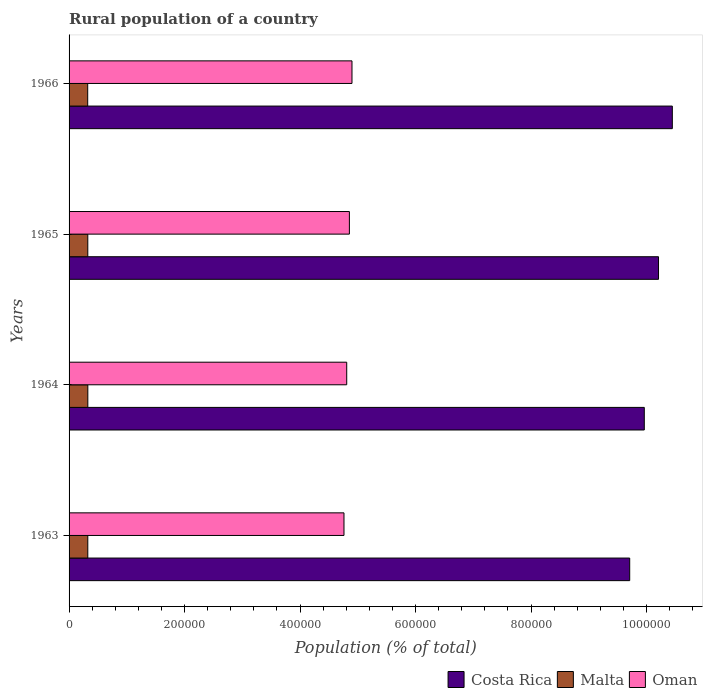How many different coloured bars are there?
Your response must be concise. 3. How many groups of bars are there?
Provide a short and direct response. 4. Are the number of bars per tick equal to the number of legend labels?
Keep it short and to the point. Yes. In how many cases, is the number of bars for a given year not equal to the number of legend labels?
Your answer should be compact. 0. What is the rural population in Oman in 1965?
Provide a succinct answer. 4.85e+05. Across all years, what is the maximum rural population in Costa Rica?
Give a very brief answer. 1.04e+06. Across all years, what is the minimum rural population in Oman?
Offer a very short reply. 4.76e+05. In which year was the rural population in Malta maximum?
Offer a very short reply. 1964. What is the total rural population in Malta in the graph?
Your answer should be compact. 1.30e+05. What is the difference between the rural population in Oman in 1964 and that in 1965?
Your response must be concise. -4614. What is the difference between the rural population in Costa Rica in 1966 and the rural population in Oman in 1963?
Give a very brief answer. 5.69e+05. What is the average rural population in Costa Rica per year?
Give a very brief answer. 1.01e+06. In the year 1966, what is the difference between the rural population in Malta and rural population in Oman?
Ensure brevity in your answer.  -4.58e+05. What is the ratio of the rural population in Malta in 1963 to that in 1964?
Give a very brief answer. 1. Is the rural population in Malta in 1965 less than that in 1966?
Provide a short and direct response. No. What is the difference between the highest and the lowest rural population in Malta?
Your answer should be very brief. 227. In how many years, is the rural population in Costa Rica greater than the average rural population in Costa Rica taken over all years?
Give a very brief answer. 2. What does the 1st bar from the bottom in 1963 represents?
Provide a succinct answer. Costa Rica. How many bars are there?
Ensure brevity in your answer.  12. How many years are there in the graph?
Ensure brevity in your answer.  4. Does the graph contain any zero values?
Offer a terse response. No. Does the graph contain grids?
Give a very brief answer. No. Where does the legend appear in the graph?
Offer a terse response. Bottom right. How many legend labels are there?
Your answer should be very brief. 3. What is the title of the graph?
Provide a succinct answer. Rural population of a country. Does "Togo" appear as one of the legend labels in the graph?
Give a very brief answer. No. What is the label or title of the X-axis?
Make the answer very short. Population (% of total). What is the label or title of the Y-axis?
Ensure brevity in your answer.  Years. What is the Population (% of total) of Costa Rica in 1963?
Provide a short and direct response. 9.71e+05. What is the Population (% of total) in Malta in 1963?
Offer a terse response. 3.24e+04. What is the Population (% of total) in Oman in 1963?
Provide a succinct answer. 4.76e+05. What is the Population (% of total) of Costa Rica in 1964?
Provide a short and direct response. 9.96e+05. What is the Population (% of total) in Malta in 1964?
Make the answer very short. 3.25e+04. What is the Population (% of total) in Oman in 1964?
Your response must be concise. 4.81e+05. What is the Population (% of total) in Costa Rica in 1965?
Your answer should be very brief. 1.02e+06. What is the Population (% of total) in Malta in 1965?
Your response must be concise. 3.24e+04. What is the Population (% of total) of Oman in 1965?
Provide a short and direct response. 4.85e+05. What is the Population (% of total) in Costa Rica in 1966?
Offer a terse response. 1.04e+06. What is the Population (% of total) in Malta in 1966?
Provide a short and direct response. 3.23e+04. What is the Population (% of total) in Oman in 1966?
Offer a terse response. 4.90e+05. Across all years, what is the maximum Population (% of total) of Costa Rica?
Give a very brief answer. 1.04e+06. Across all years, what is the maximum Population (% of total) of Malta?
Offer a terse response. 3.25e+04. Across all years, what is the maximum Population (% of total) in Oman?
Your answer should be compact. 4.90e+05. Across all years, what is the minimum Population (% of total) in Costa Rica?
Provide a short and direct response. 9.71e+05. Across all years, what is the minimum Population (% of total) in Malta?
Offer a very short reply. 3.23e+04. Across all years, what is the minimum Population (% of total) in Oman?
Offer a very short reply. 4.76e+05. What is the total Population (% of total) in Costa Rica in the graph?
Ensure brevity in your answer.  4.03e+06. What is the total Population (% of total) of Malta in the graph?
Ensure brevity in your answer.  1.30e+05. What is the total Population (% of total) in Oman in the graph?
Keep it short and to the point. 1.93e+06. What is the difference between the Population (% of total) of Costa Rica in 1963 and that in 1964?
Offer a terse response. -2.53e+04. What is the difference between the Population (% of total) in Malta in 1963 and that in 1964?
Your answer should be compact. -68. What is the difference between the Population (% of total) of Oman in 1963 and that in 1964?
Provide a succinct answer. -4753. What is the difference between the Population (% of total) in Costa Rica in 1963 and that in 1965?
Your answer should be very brief. -4.99e+04. What is the difference between the Population (% of total) of Oman in 1963 and that in 1965?
Your answer should be compact. -9367. What is the difference between the Population (% of total) in Costa Rica in 1963 and that in 1966?
Offer a very short reply. -7.38e+04. What is the difference between the Population (% of total) of Malta in 1963 and that in 1966?
Make the answer very short. 159. What is the difference between the Population (% of total) in Oman in 1963 and that in 1966?
Make the answer very short. -1.39e+04. What is the difference between the Population (% of total) in Costa Rica in 1964 and that in 1965?
Make the answer very short. -2.46e+04. What is the difference between the Population (% of total) of Malta in 1964 and that in 1965?
Make the answer very short. 53. What is the difference between the Population (% of total) of Oman in 1964 and that in 1965?
Provide a succinct answer. -4614. What is the difference between the Population (% of total) in Costa Rica in 1964 and that in 1966?
Give a very brief answer. -4.86e+04. What is the difference between the Population (% of total) of Malta in 1964 and that in 1966?
Give a very brief answer. 227. What is the difference between the Population (% of total) of Oman in 1964 and that in 1966?
Offer a terse response. -9109. What is the difference between the Population (% of total) in Costa Rica in 1965 and that in 1966?
Provide a succinct answer. -2.39e+04. What is the difference between the Population (% of total) in Malta in 1965 and that in 1966?
Your answer should be compact. 174. What is the difference between the Population (% of total) in Oman in 1965 and that in 1966?
Offer a very short reply. -4495. What is the difference between the Population (% of total) of Costa Rica in 1963 and the Population (% of total) of Malta in 1964?
Ensure brevity in your answer.  9.38e+05. What is the difference between the Population (% of total) in Costa Rica in 1963 and the Population (% of total) in Oman in 1964?
Keep it short and to the point. 4.90e+05. What is the difference between the Population (% of total) in Malta in 1963 and the Population (% of total) in Oman in 1964?
Ensure brevity in your answer.  -4.48e+05. What is the difference between the Population (% of total) in Costa Rica in 1963 and the Population (% of total) in Malta in 1965?
Provide a short and direct response. 9.38e+05. What is the difference between the Population (% of total) of Costa Rica in 1963 and the Population (% of total) of Oman in 1965?
Your response must be concise. 4.85e+05. What is the difference between the Population (% of total) of Malta in 1963 and the Population (% of total) of Oman in 1965?
Your response must be concise. -4.53e+05. What is the difference between the Population (% of total) of Costa Rica in 1963 and the Population (% of total) of Malta in 1966?
Offer a terse response. 9.39e+05. What is the difference between the Population (% of total) in Costa Rica in 1963 and the Population (% of total) in Oman in 1966?
Ensure brevity in your answer.  4.81e+05. What is the difference between the Population (% of total) in Malta in 1963 and the Population (% of total) in Oman in 1966?
Provide a short and direct response. -4.57e+05. What is the difference between the Population (% of total) of Costa Rica in 1964 and the Population (% of total) of Malta in 1965?
Provide a succinct answer. 9.64e+05. What is the difference between the Population (% of total) in Costa Rica in 1964 and the Population (% of total) in Oman in 1965?
Provide a succinct answer. 5.11e+05. What is the difference between the Population (% of total) in Malta in 1964 and the Population (% of total) in Oman in 1965?
Make the answer very short. -4.53e+05. What is the difference between the Population (% of total) in Costa Rica in 1964 and the Population (% of total) in Malta in 1966?
Make the answer very short. 9.64e+05. What is the difference between the Population (% of total) in Costa Rica in 1964 and the Population (% of total) in Oman in 1966?
Make the answer very short. 5.06e+05. What is the difference between the Population (% of total) in Malta in 1964 and the Population (% of total) in Oman in 1966?
Keep it short and to the point. -4.57e+05. What is the difference between the Population (% of total) of Costa Rica in 1965 and the Population (% of total) of Malta in 1966?
Ensure brevity in your answer.  9.88e+05. What is the difference between the Population (% of total) of Costa Rica in 1965 and the Population (% of total) of Oman in 1966?
Ensure brevity in your answer.  5.31e+05. What is the difference between the Population (% of total) in Malta in 1965 and the Population (% of total) in Oman in 1966?
Offer a terse response. -4.57e+05. What is the average Population (% of total) in Costa Rica per year?
Ensure brevity in your answer.  1.01e+06. What is the average Population (% of total) of Malta per year?
Provide a succinct answer. 3.24e+04. What is the average Population (% of total) in Oman per year?
Provide a succinct answer. 4.83e+05. In the year 1963, what is the difference between the Population (% of total) in Costa Rica and Population (% of total) in Malta?
Make the answer very short. 9.38e+05. In the year 1963, what is the difference between the Population (% of total) in Costa Rica and Population (% of total) in Oman?
Provide a succinct answer. 4.95e+05. In the year 1963, what is the difference between the Population (% of total) of Malta and Population (% of total) of Oman?
Provide a succinct answer. -4.44e+05. In the year 1964, what is the difference between the Population (% of total) in Costa Rica and Population (% of total) in Malta?
Make the answer very short. 9.64e+05. In the year 1964, what is the difference between the Population (% of total) of Costa Rica and Population (% of total) of Oman?
Make the answer very short. 5.15e+05. In the year 1964, what is the difference between the Population (% of total) of Malta and Population (% of total) of Oman?
Your answer should be compact. -4.48e+05. In the year 1965, what is the difference between the Population (% of total) in Costa Rica and Population (% of total) in Malta?
Provide a short and direct response. 9.88e+05. In the year 1965, what is the difference between the Population (% of total) of Costa Rica and Population (% of total) of Oman?
Provide a short and direct response. 5.35e+05. In the year 1965, what is the difference between the Population (% of total) in Malta and Population (% of total) in Oman?
Ensure brevity in your answer.  -4.53e+05. In the year 1966, what is the difference between the Population (% of total) in Costa Rica and Population (% of total) in Malta?
Make the answer very short. 1.01e+06. In the year 1966, what is the difference between the Population (% of total) of Costa Rica and Population (% of total) of Oman?
Your response must be concise. 5.55e+05. In the year 1966, what is the difference between the Population (% of total) in Malta and Population (% of total) in Oman?
Give a very brief answer. -4.58e+05. What is the ratio of the Population (% of total) of Costa Rica in 1963 to that in 1964?
Your answer should be compact. 0.97. What is the ratio of the Population (% of total) in Malta in 1963 to that in 1964?
Offer a very short reply. 1. What is the ratio of the Population (% of total) of Costa Rica in 1963 to that in 1965?
Offer a terse response. 0.95. What is the ratio of the Population (% of total) in Malta in 1963 to that in 1965?
Your answer should be very brief. 1. What is the ratio of the Population (% of total) of Oman in 1963 to that in 1965?
Your answer should be very brief. 0.98. What is the ratio of the Population (% of total) in Costa Rica in 1963 to that in 1966?
Give a very brief answer. 0.93. What is the ratio of the Population (% of total) in Malta in 1963 to that in 1966?
Keep it short and to the point. 1. What is the ratio of the Population (% of total) of Oman in 1963 to that in 1966?
Offer a terse response. 0.97. What is the ratio of the Population (% of total) of Costa Rica in 1964 to that in 1965?
Provide a short and direct response. 0.98. What is the ratio of the Population (% of total) of Costa Rica in 1964 to that in 1966?
Offer a very short reply. 0.95. What is the ratio of the Population (% of total) in Malta in 1964 to that in 1966?
Your answer should be compact. 1.01. What is the ratio of the Population (% of total) of Oman in 1964 to that in 1966?
Your response must be concise. 0.98. What is the ratio of the Population (% of total) of Costa Rica in 1965 to that in 1966?
Give a very brief answer. 0.98. What is the ratio of the Population (% of total) of Malta in 1965 to that in 1966?
Make the answer very short. 1.01. What is the ratio of the Population (% of total) of Oman in 1965 to that in 1966?
Offer a very short reply. 0.99. What is the difference between the highest and the second highest Population (% of total) in Costa Rica?
Provide a short and direct response. 2.39e+04. What is the difference between the highest and the second highest Population (% of total) in Malta?
Ensure brevity in your answer.  53. What is the difference between the highest and the second highest Population (% of total) in Oman?
Keep it short and to the point. 4495. What is the difference between the highest and the lowest Population (% of total) of Costa Rica?
Make the answer very short. 7.38e+04. What is the difference between the highest and the lowest Population (% of total) in Malta?
Provide a succinct answer. 227. What is the difference between the highest and the lowest Population (% of total) of Oman?
Ensure brevity in your answer.  1.39e+04. 